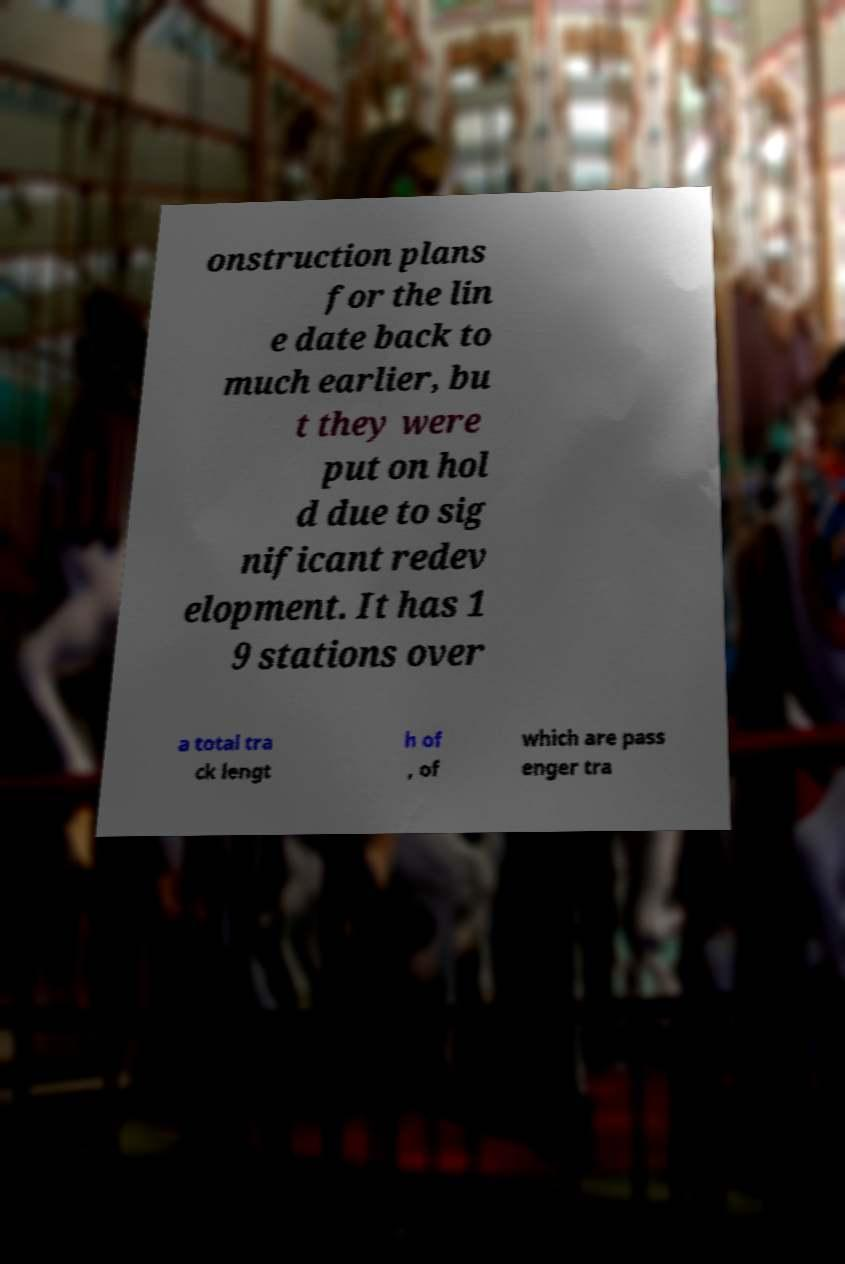Please identify and transcribe the text found in this image. onstruction plans for the lin e date back to much earlier, bu t they were put on hol d due to sig nificant redev elopment. It has 1 9 stations over a total tra ck lengt h of , of which are pass enger tra 